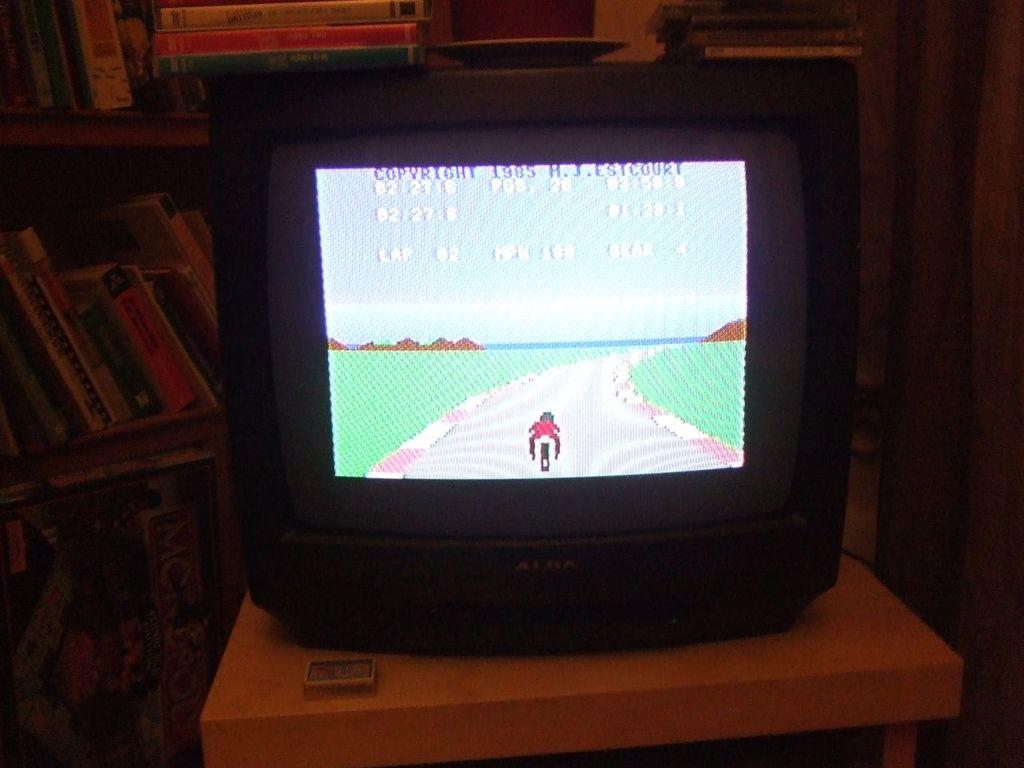Provide a one-sentence caption for the provided image. A game with a 1985 copyright is displayed on a television screen. 